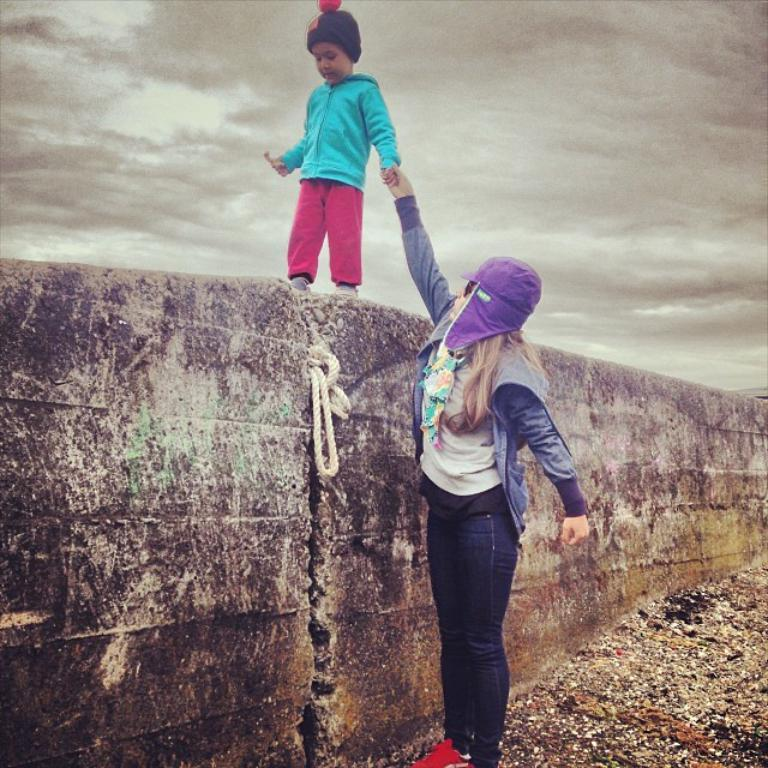What is the woman doing in the image? The woman is standing on the ground in the image. What is the kid holding in the image? The kid is holding an object in the image. Where is the kid located in the image? The kid is walking on a wall in the image. What can be seen in the background of the image? The sky is visible in the background of the image, and clouds are present in the sky. What type of reaction can be seen from the baby in the image? There is no baby present in the image, so it is not possible to determine any reactions. 